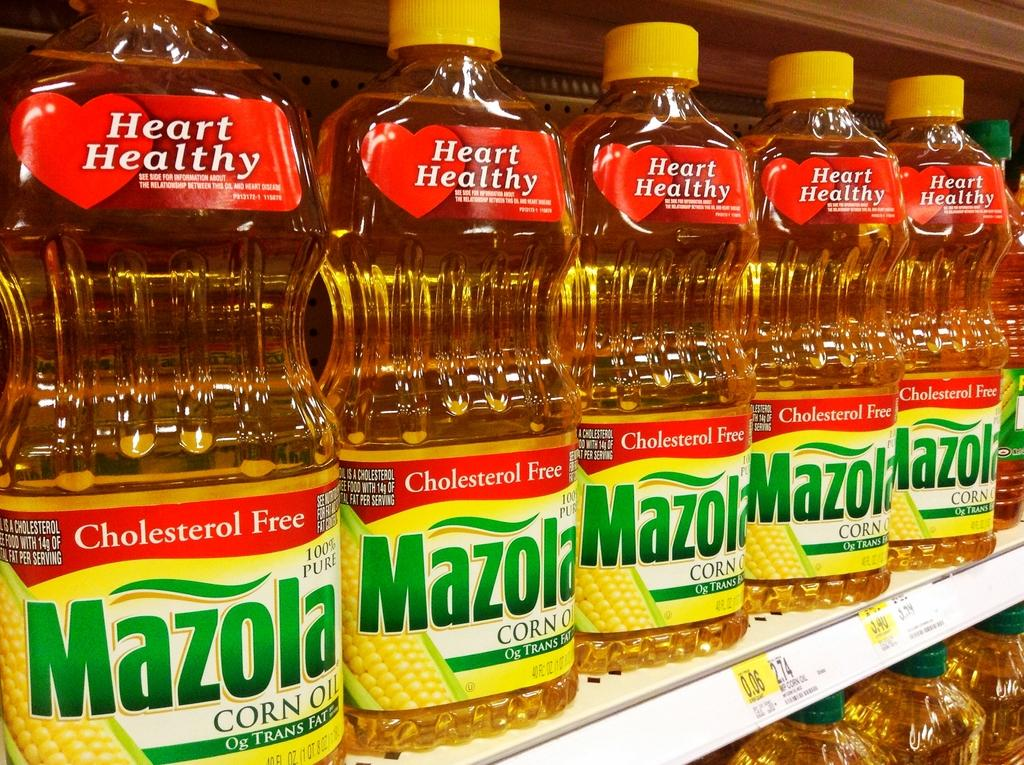Provide a one-sentence caption for the provided image. mazola oil sits on the shelfs of the grocery store. 